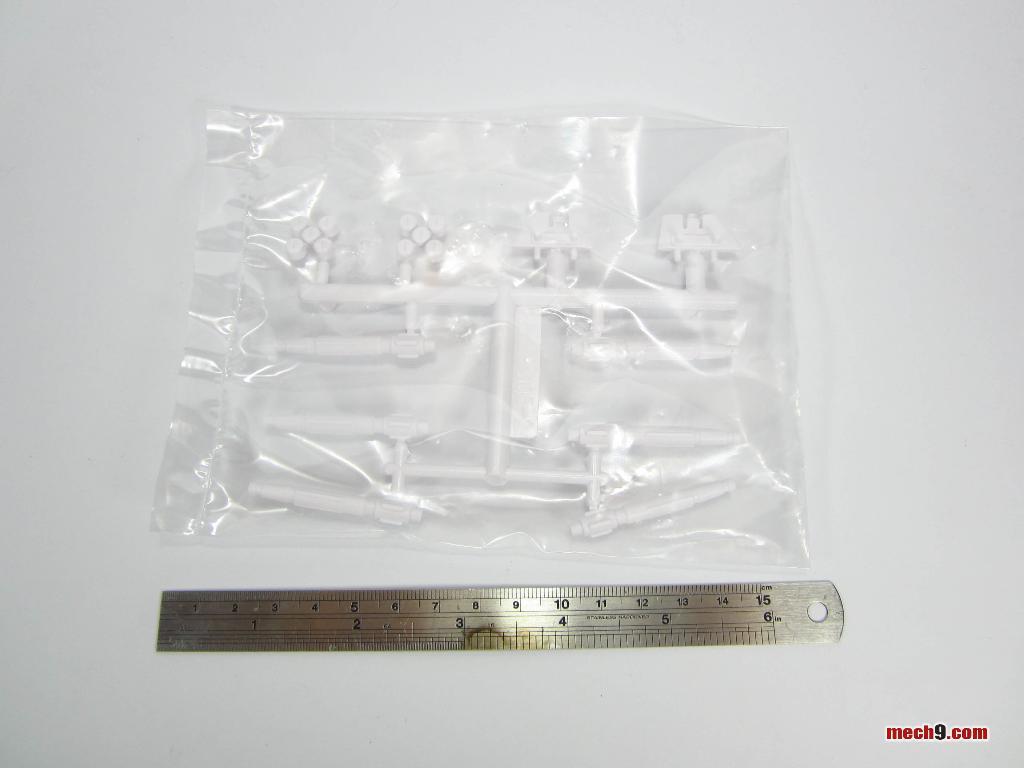What website is this from?
Keep it short and to the point. Mech9.com. 